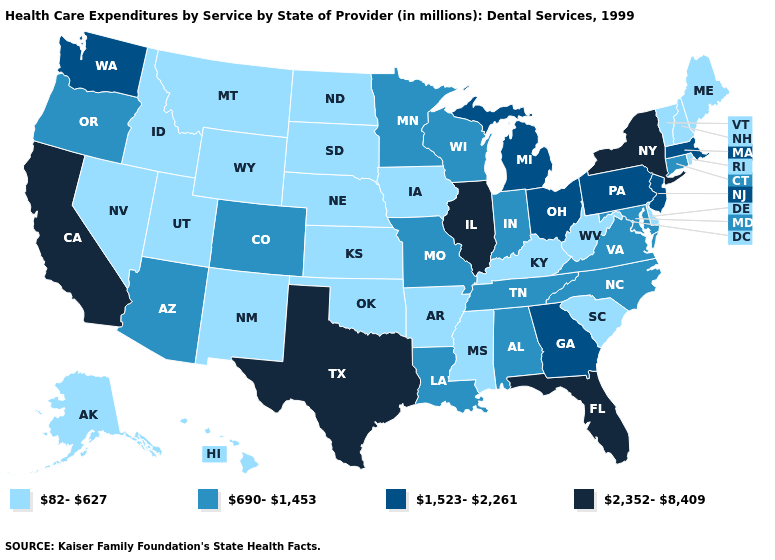What is the highest value in the MidWest ?
Write a very short answer. 2,352-8,409. What is the highest value in the South ?
Give a very brief answer. 2,352-8,409. Does Kansas have the lowest value in the USA?
Keep it brief. Yes. Name the states that have a value in the range 690-1,453?
Concise answer only. Alabama, Arizona, Colorado, Connecticut, Indiana, Louisiana, Maryland, Minnesota, Missouri, North Carolina, Oregon, Tennessee, Virginia, Wisconsin. What is the value of Oregon?
Write a very short answer. 690-1,453. Name the states that have a value in the range 82-627?
Concise answer only. Alaska, Arkansas, Delaware, Hawaii, Idaho, Iowa, Kansas, Kentucky, Maine, Mississippi, Montana, Nebraska, Nevada, New Hampshire, New Mexico, North Dakota, Oklahoma, Rhode Island, South Carolina, South Dakota, Utah, Vermont, West Virginia, Wyoming. Among the states that border South Dakota , which have the highest value?
Write a very short answer. Minnesota. Name the states that have a value in the range 82-627?
Short answer required. Alaska, Arkansas, Delaware, Hawaii, Idaho, Iowa, Kansas, Kentucky, Maine, Mississippi, Montana, Nebraska, Nevada, New Hampshire, New Mexico, North Dakota, Oklahoma, Rhode Island, South Carolina, South Dakota, Utah, Vermont, West Virginia, Wyoming. Does Utah have a lower value than Alabama?
Concise answer only. Yes. What is the value of Connecticut?
Short answer required. 690-1,453. Does Nebraska have the lowest value in the MidWest?
Be succinct. Yes. Among the states that border Florida , does Georgia have the lowest value?
Be succinct. No. What is the lowest value in the MidWest?
Quick response, please. 82-627. Does the map have missing data?
Answer briefly. No. What is the value of Utah?
Concise answer only. 82-627. 